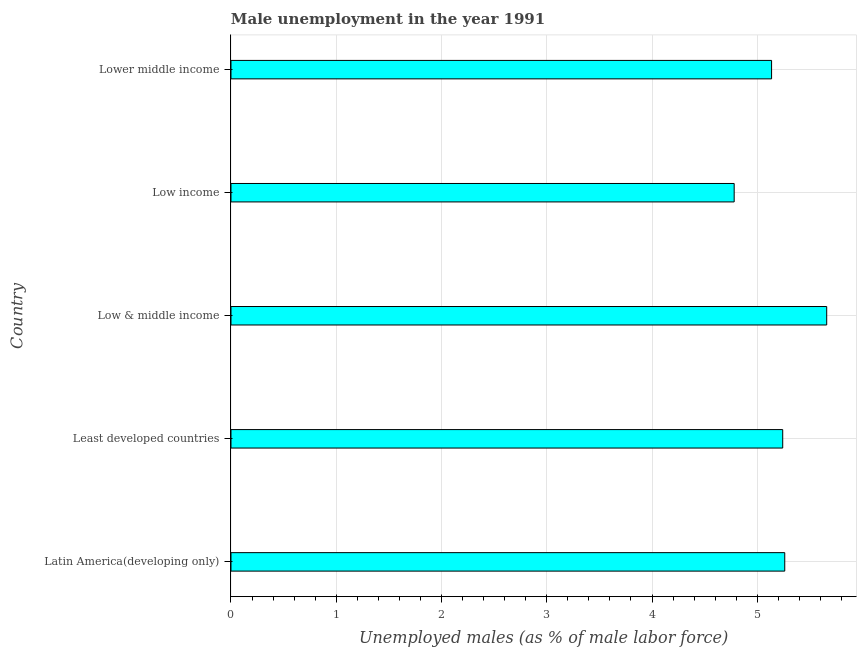What is the title of the graph?
Give a very brief answer. Male unemployment in the year 1991. What is the label or title of the X-axis?
Your response must be concise. Unemployed males (as % of male labor force). What is the label or title of the Y-axis?
Your answer should be very brief. Country. What is the unemployed males population in Latin America(developing only)?
Provide a succinct answer. 5.26. Across all countries, what is the maximum unemployed males population?
Your answer should be very brief. 5.66. Across all countries, what is the minimum unemployed males population?
Offer a terse response. 4.78. In which country was the unemployed males population maximum?
Your answer should be compact. Low & middle income. What is the sum of the unemployed males population?
Keep it short and to the point. 26.08. What is the difference between the unemployed males population in Least developed countries and Lower middle income?
Offer a terse response. 0.11. What is the average unemployed males population per country?
Give a very brief answer. 5.21. What is the median unemployed males population?
Your answer should be compact. 5.24. In how many countries, is the unemployed males population greater than 0.4 %?
Your answer should be very brief. 5. What is the ratio of the unemployed males population in Latin America(developing only) to that in Least developed countries?
Make the answer very short. 1. Is the unemployed males population in Least developed countries less than that in Lower middle income?
Your response must be concise. No. Is the difference between the unemployed males population in Least developed countries and Low income greater than the difference between any two countries?
Give a very brief answer. No. What is the difference between the highest and the second highest unemployed males population?
Make the answer very short. 0.4. Is the sum of the unemployed males population in Latin America(developing only) and Lower middle income greater than the maximum unemployed males population across all countries?
Offer a very short reply. Yes. In how many countries, is the unemployed males population greater than the average unemployed males population taken over all countries?
Your answer should be very brief. 3. How many bars are there?
Your answer should be very brief. 5. How many countries are there in the graph?
Ensure brevity in your answer.  5. What is the Unemployed males (as % of male labor force) in Latin America(developing only)?
Offer a very short reply. 5.26. What is the Unemployed males (as % of male labor force) of Least developed countries?
Offer a terse response. 5.24. What is the Unemployed males (as % of male labor force) in Low & middle income?
Provide a succinct answer. 5.66. What is the Unemployed males (as % of male labor force) of Low income?
Provide a short and direct response. 4.78. What is the Unemployed males (as % of male labor force) of Lower middle income?
Provide a short and direct response. 5.14. What is the difference between the Unemployed males (as % of male labor force) in Latin America(developing only) and Least developed countries?
Provide a short and direct response. 0.02. What is the difference between the Unemployed males (as % of male labor force) in Latin America(developing only) and Low & middle income?
Make the answer very short. -0.4. What is the difference between the Unemployed males (as % of male labor force) in Latin America(developing only) and Low income?
Offer a very short reply. 0.48. What is the difference between the Unemployed males (as % of male labor force) in Latin America(developing only) and Lower middle income?
Give a very brief answer. 0.13. What is the difference between the Unemployed males (as % of male labor force) in Least developed countries and Low & middle income?
Provide a succinct answer. -0.42. What is the difference between the Unemployed males (as % of male labor force) in Least developed countries and Low income?
Provide a short and direct response. 0.46. What is the difference between the Unemployed males (as % of male labor force) in Least developed countries and Lower middle income?
Offer a very short reply. 0.11. What is the difference between the Unemployed males (as % of male labor force) in Low & middle income and Low income?
Provide a succinct answer. 0.88. What is the difference between the Unemployed males (as % of male labor force) in Low & middle income and Lower middle income?
Keep it short and to the point. 0.52. What is the difference between the Unemployed males (as % of male labor force) in Low income and Lower middle income?
Ensure brevity in your answer.  -0.36. What is the ratio of the Unemployed males (as % of male labor force) in Latin America(developing only) to that in Least developed countries?
Your answer should be very brief. 1. What is the ratio of the Unemployed males (as % of male labor force) in Latin America(developing only) to that in Low & middle income?
Ensure brevity in your answer.  0.93. What is the ratio of the Unemployed males (as % of male labor force) in Latin America(developing only) to that in Low income?
Your answer should be very brief. 1.1. What is the ratio of the Unemployed males (as % of male labor force) in Latin America(developing only) to that in Lower middle income?
Your response must be concise. 1.02. What is the ratio of the Unemployed males (as % of male labor force) in Least developed countries to that in Low & middle income?
Offer a very short reply. 0.93. What is the ratio of the Unemployed males (as % of male labor force) in Least developed countries to that in Low income?
Your response must be concise. 1.1. What is the ratio of the Unemployed males (as % of male labor force) in Least developed countries to that in Lower middle income?
Offer a very short reply. 1.02. What is the ratio of the Unemployed males (as % of male labor force) in Low & middle income to that in Low income?
Your answer should be very brief. 1.18. What is the ratio of the Unemployed males (as % of male labor force) in Low & middle income to that in Lower middle income?
Your answer should be compact. 1.1. 